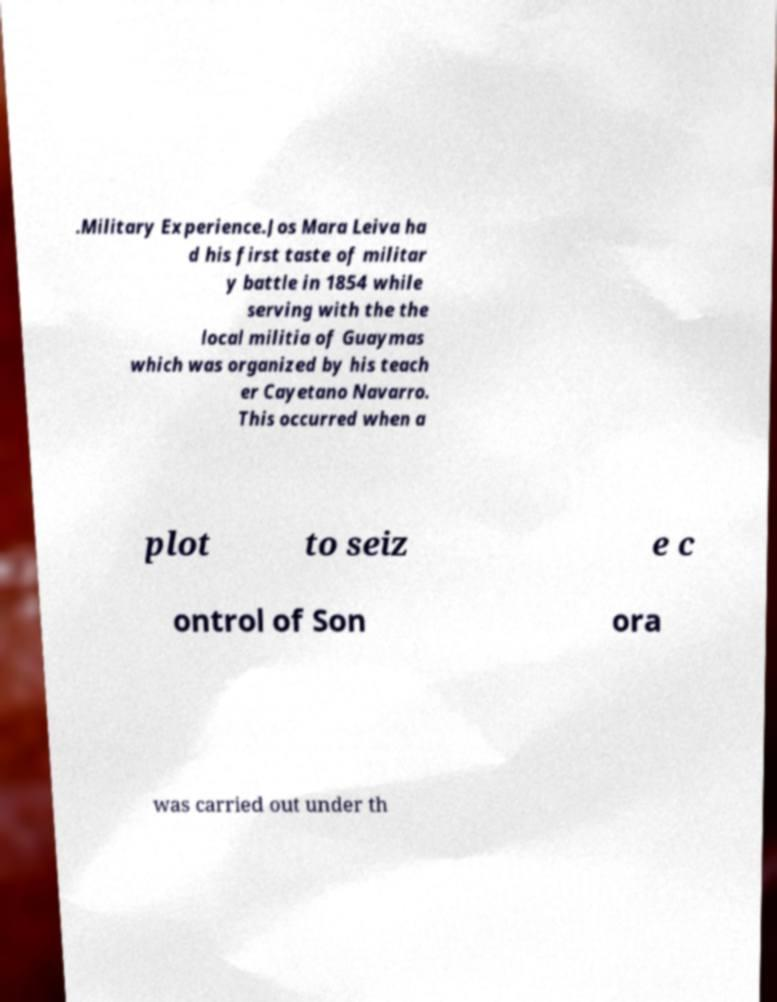Could you assist in decoding the text presented in this image and type it out clearly? .Military Experience.Jos Mara Leiva ha d his first taste of militar y battle in 1854 while serving with the the local militia of Guaymas which was organized by his teach er Cayetano Navarro. This occurred when a plot to seiz e c ontrol of Son ora was carried out under th 